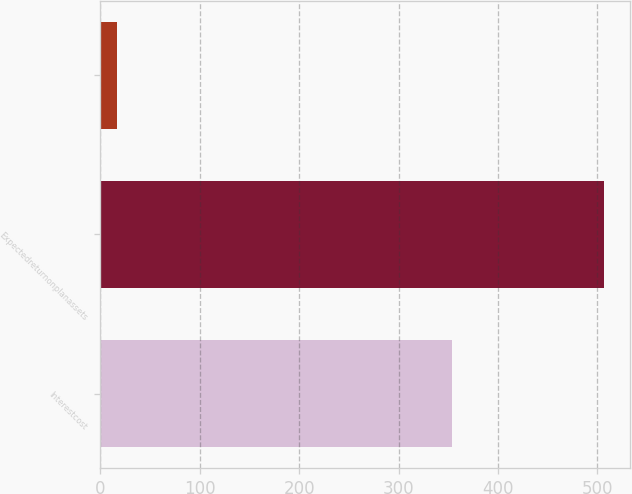Convert chart. <chart><loc_0><loc_0><loc_500><loc_500><bar_chart><fcel>Interestcost<fcel>Expectedreturnonplanassets<fcel>Unnamed: 2<nl><fcel>354<fcel>507<fcel>17<nl></chart> 